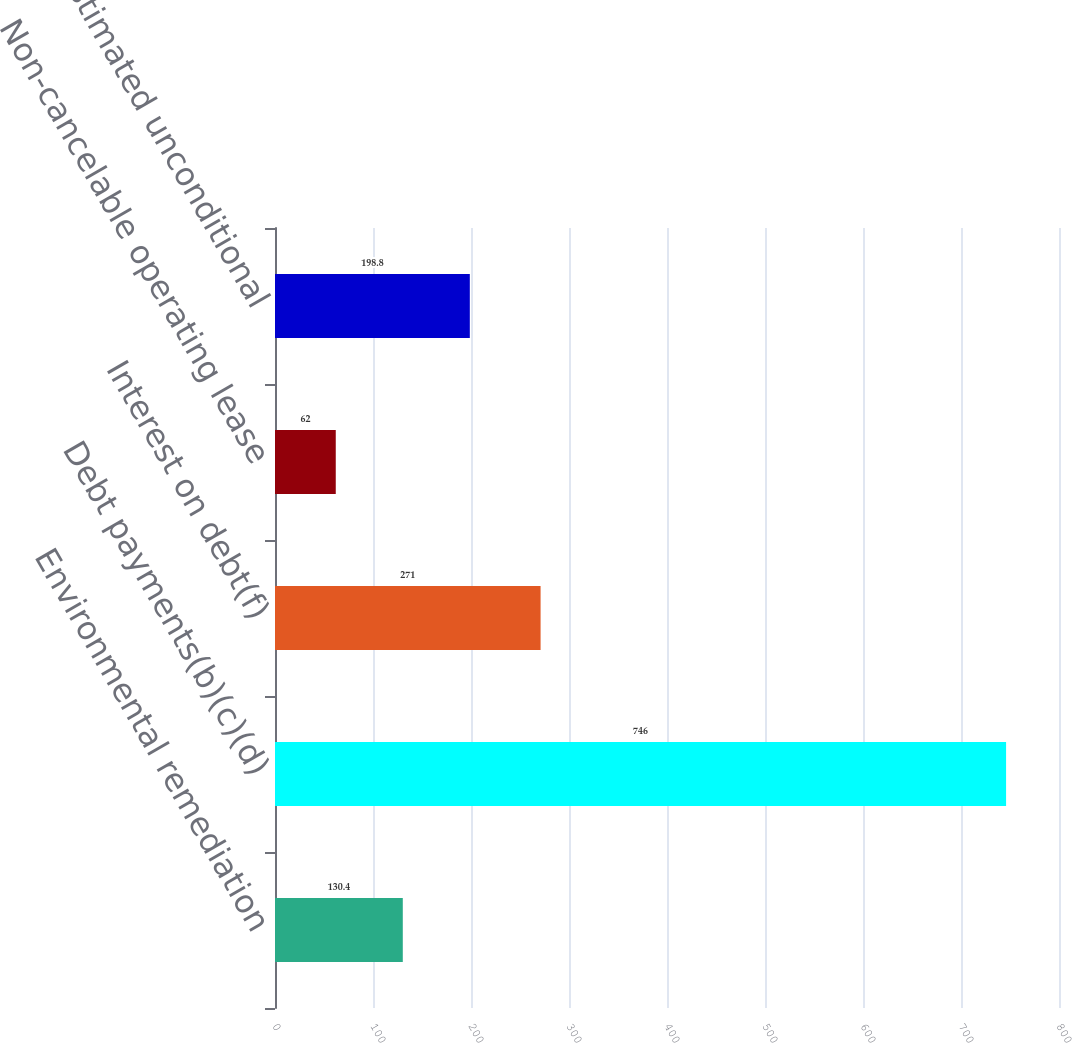Convert chart. <chart><loc_0><loc_0><loc_500><loc_500><bar_chart><fcel>Environmental remediation<fcel>Debt payments(b)(c)(d)<fcel>Interest on debt(f)<fcel>Non-cancelable operating lease<fcel>Estimated unconditional<nl><fcel>130.4<fcel>746<fcel>271<fcel>62<fcel>198.8<nl></chart> 